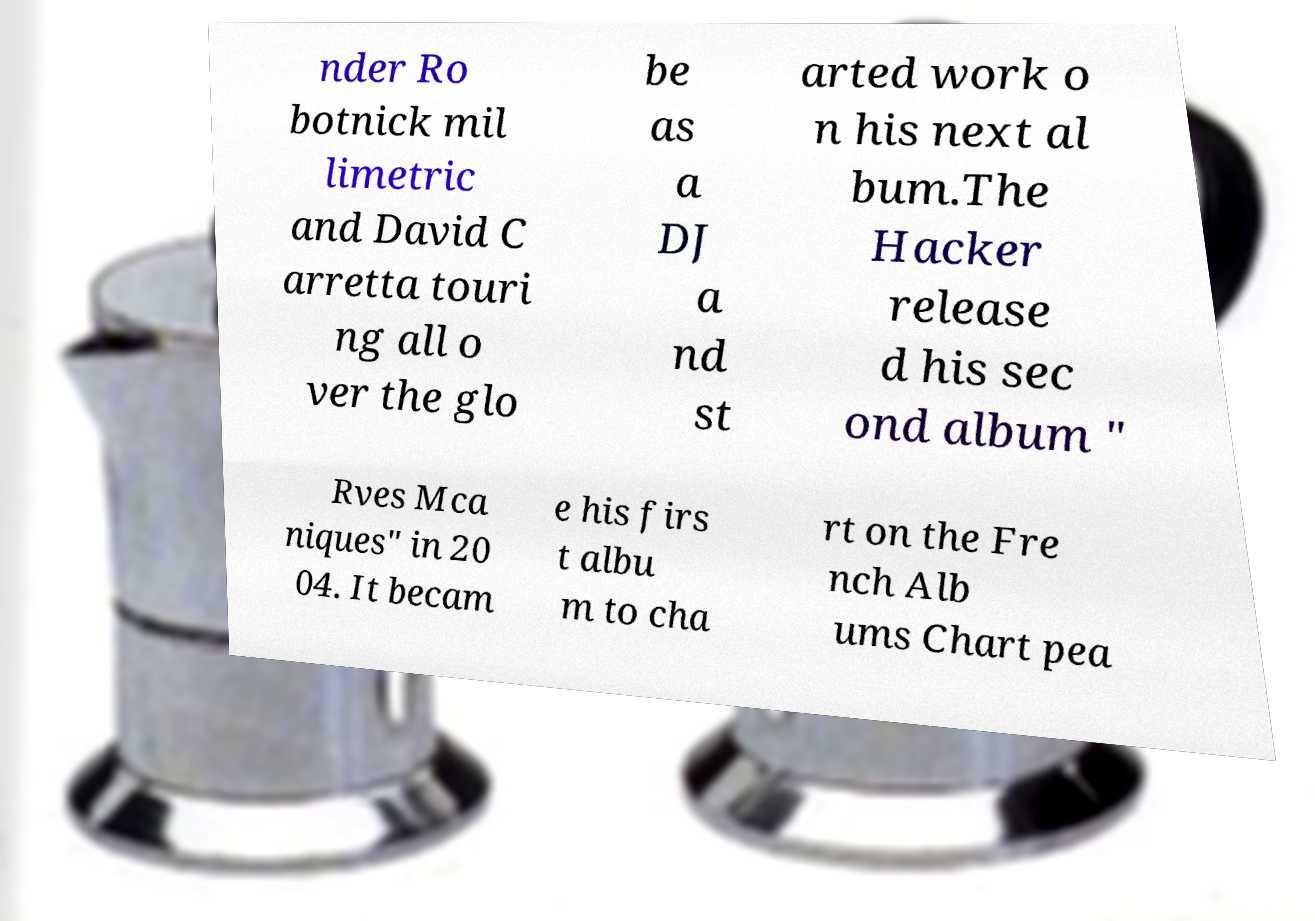Can you read and provide the text displayed in the image?This photo seems to have some interesting text. Can you extract and type it out for me? nder Ro botnick mil limetric and David C arretta touri ng all o ver the glo be as a DJ a nd st arted work o n his next al bum.The Hacker release d his sec ond album " Rves Mca niques" in 20 04. It becam e his firs t albu m to cha rt on the Fre nch Alb ums Chart pea 